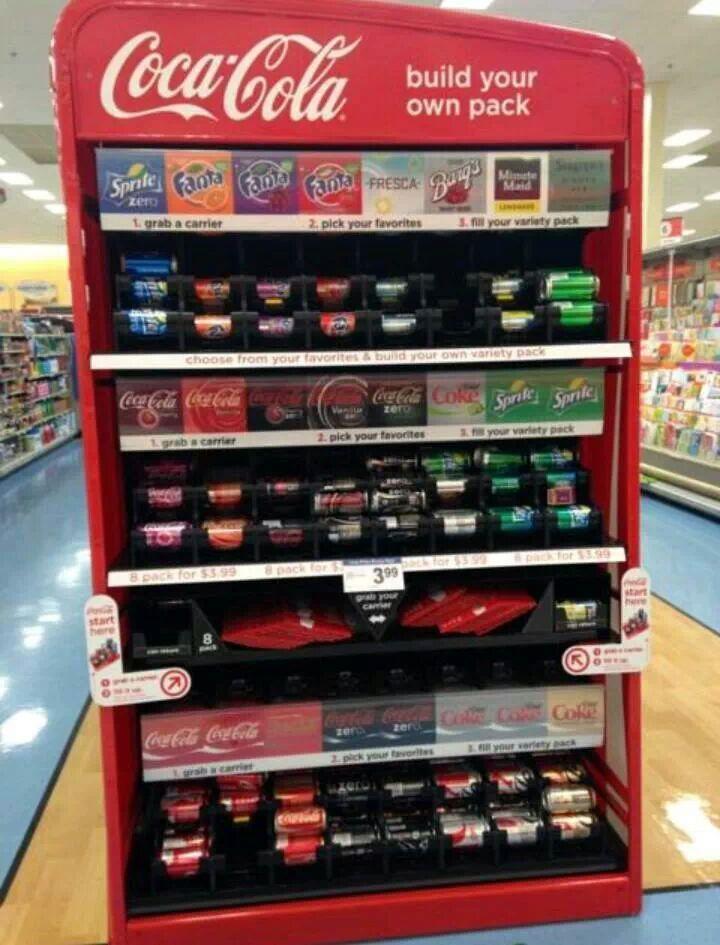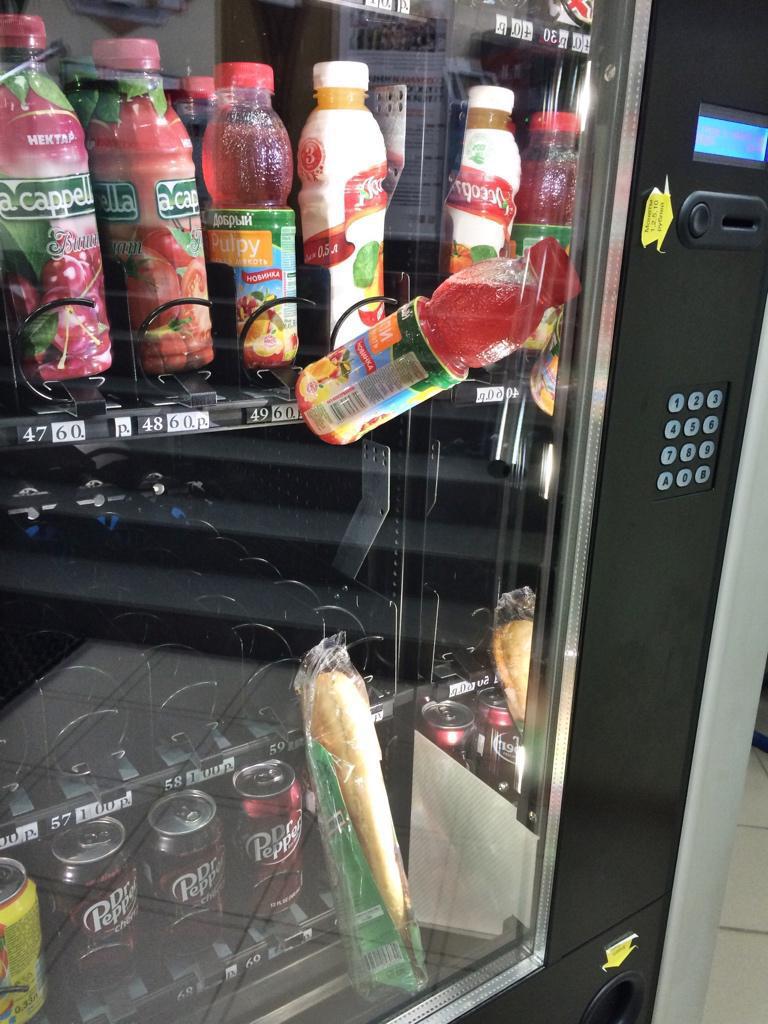The first image is the image on the left, the second image is the image on the right. Examine the images to the left and right. Is the description "At least one pack of peanut m&m's is in a vending machine in one of the images." accurate? Answer yes or no. No. The first image is the image on the left, the second image is the image on the right. For the images shown, is this caption "One image shows a vending machine front with one bottle at a diagonal, as if falling." true? Answer yes or no. Yes. 